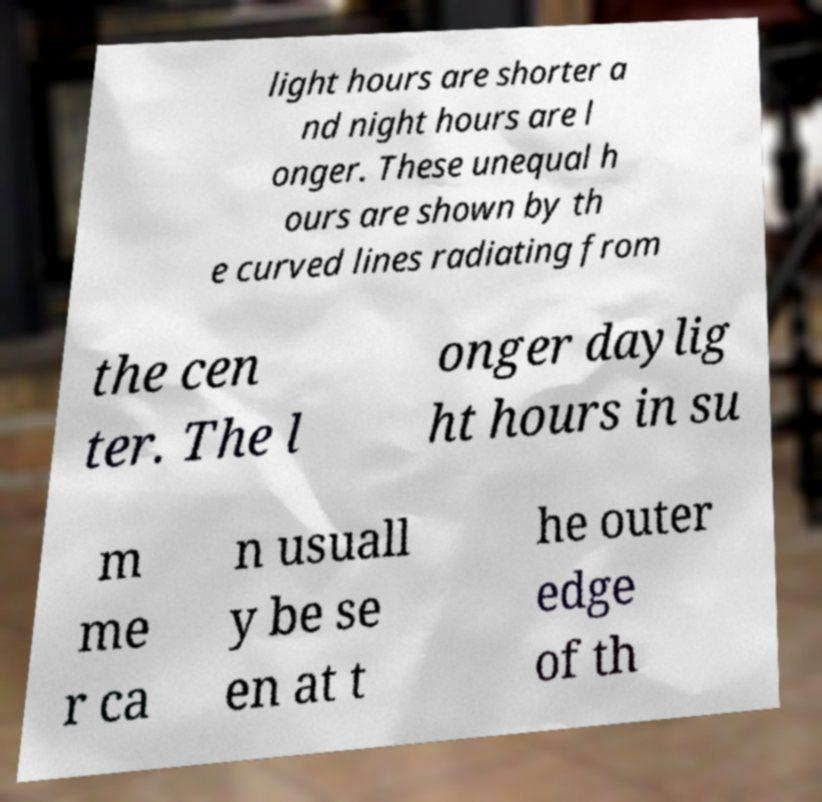What messages or text are displayed in this image? I need them in a readable, typed format. light hours are shorter a nd night hours are l onger. These unequal h ours are shown by th e curved lines radiating from the cen ter. The l onger daylig ht hours in su m me r ca n usuall y be se en at t he outer edge of th 